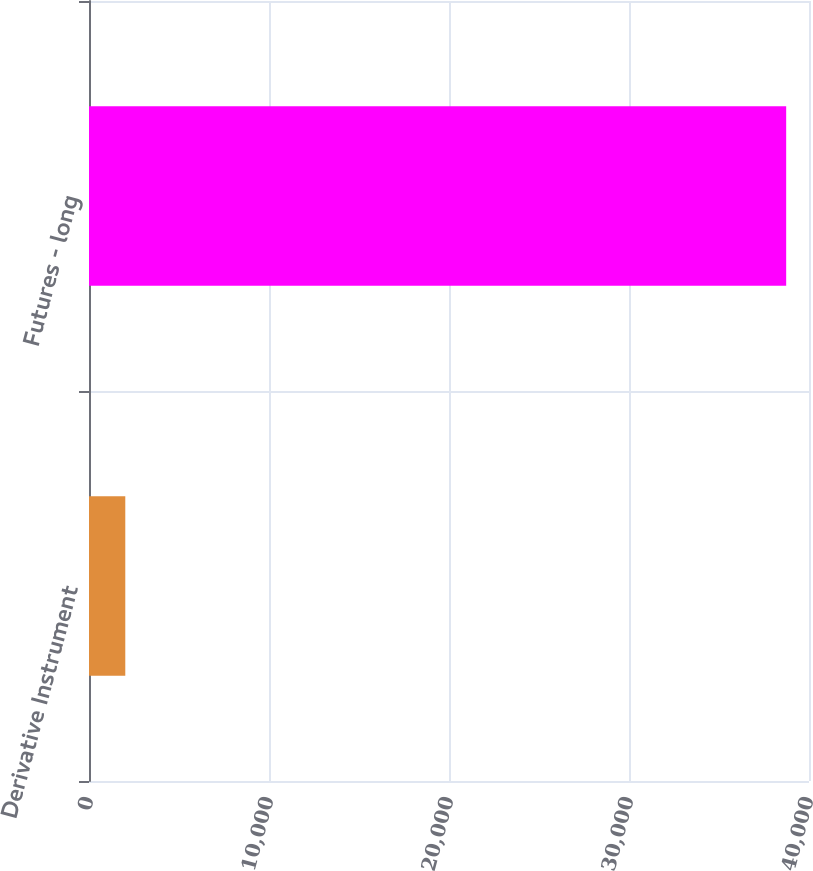<chart> <loc_0><loc_0><loc_500><loc_500><bar_chart><fcel>Derivative Instrument<fcel>Futures - long<nl><fcel>2016<fcel>38732<nl></chart> 